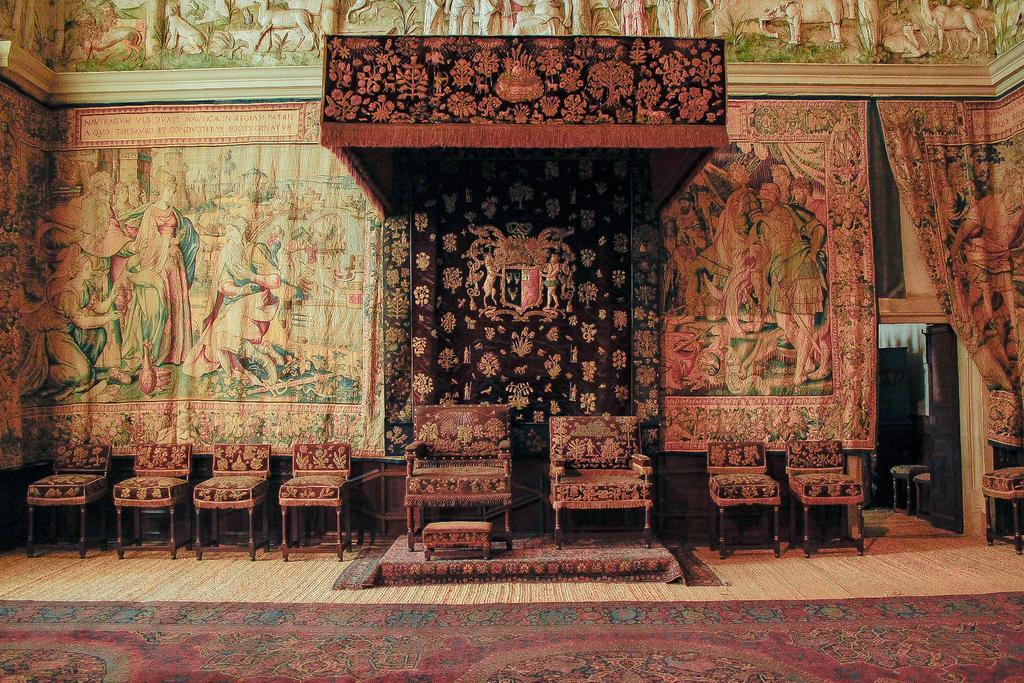Please provide a concise description of this image. In the background we can see designed curtains. At the top we can see the carvings on the wall. In this picture we can see the chairs and a stool. On the right side of the picture we can see the chairs and a door. At the bottom portion of the picture we can see the floor carpet on the floor. 